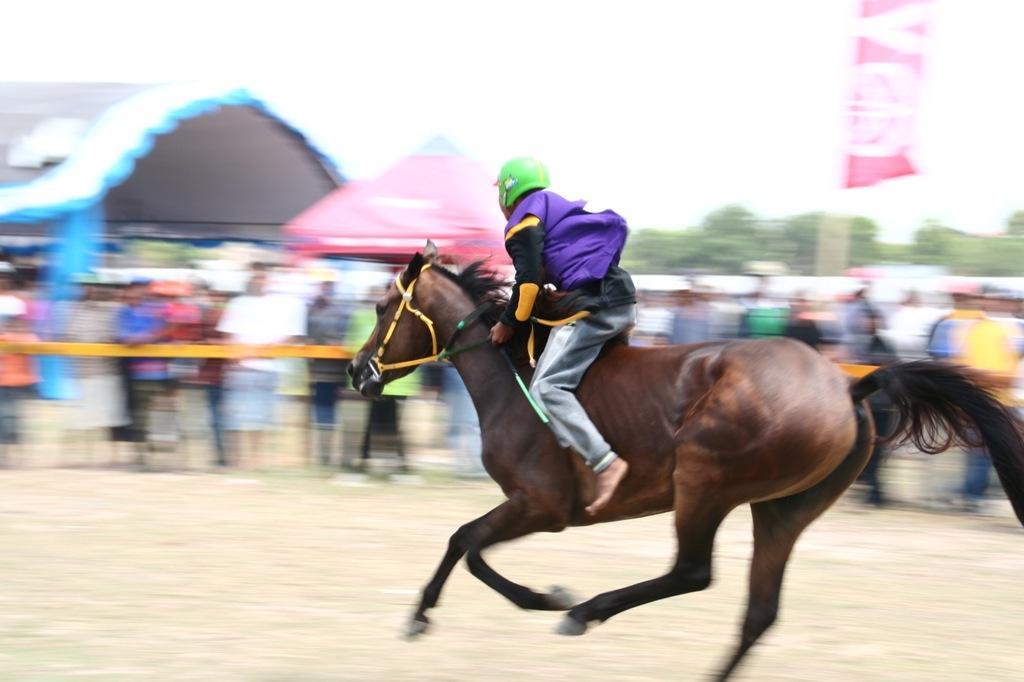How would you summarize this image in a sentence or two? In this image, the man is riding the horse. The horse is brown in color and the man is wearing blue colored jacket and a green helmet. In the background there are trees and a tent to the left of the image. The crowd are standing and staring at the horse. 